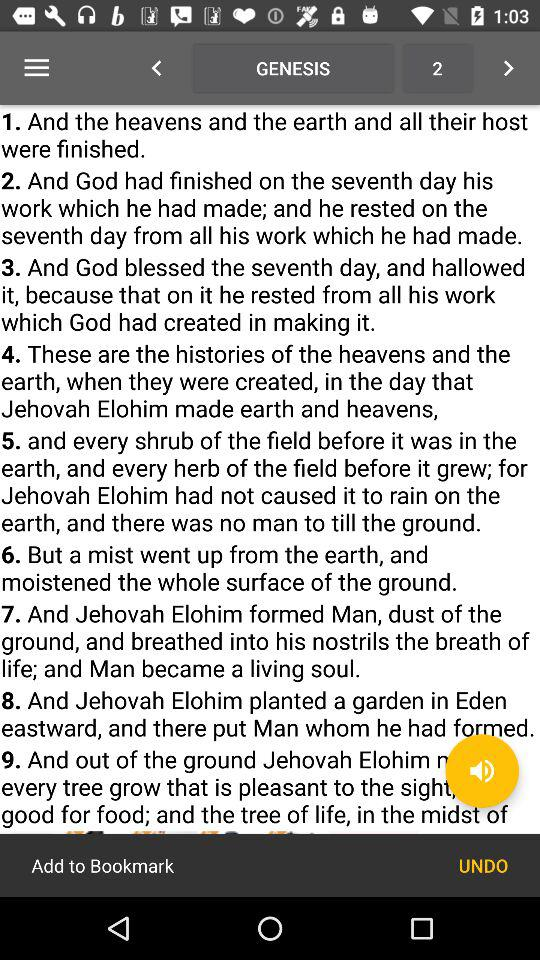Where did Jehovah Elohim plant a garden? Jehovah Elohim planted a garden in Eden to the east. 